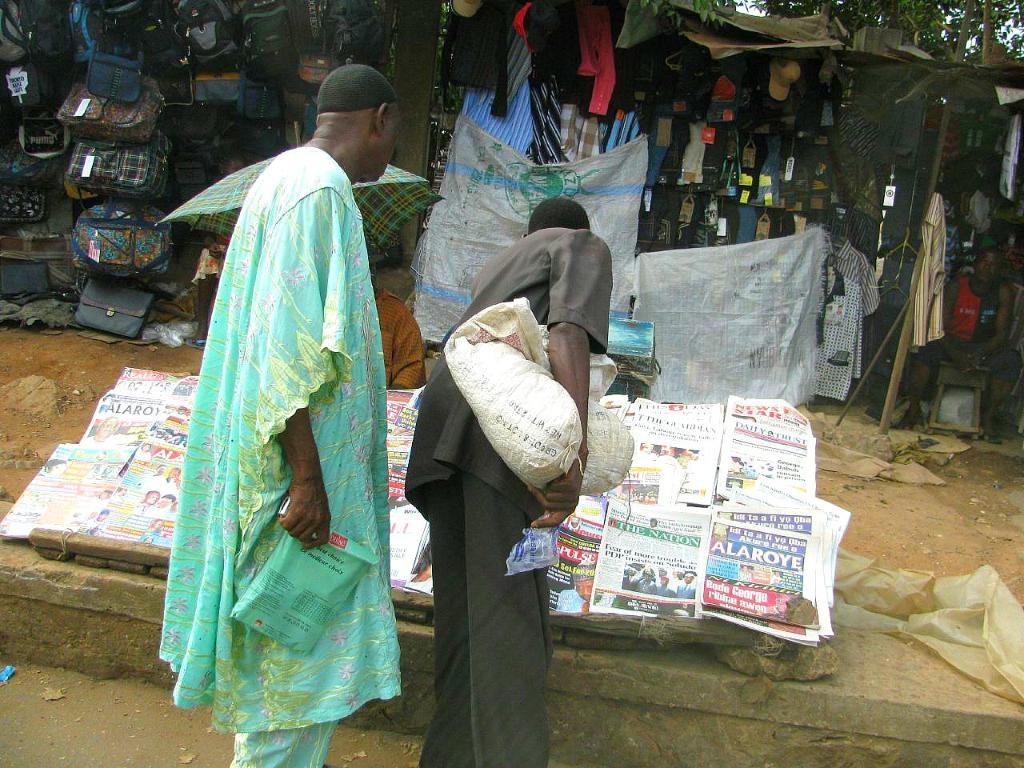What are the two men in the image doing? The two men in the image are walking. What is at the bottom of the image? There is a road at the bottom of the image. What can be seen in the background of the image? There is a shop in the background of the image. What items are available in the shop? The shop contains pants and bags. What type of hair products are available in the shop? There is no information about hair products in the image or the provided facts. --- 